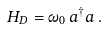<formula> <loc_0><loc_0><loc_500><loc_500>H _ { D } = \omega _ { 0 } \, a ^ { \dagger } a \, .</formula> 